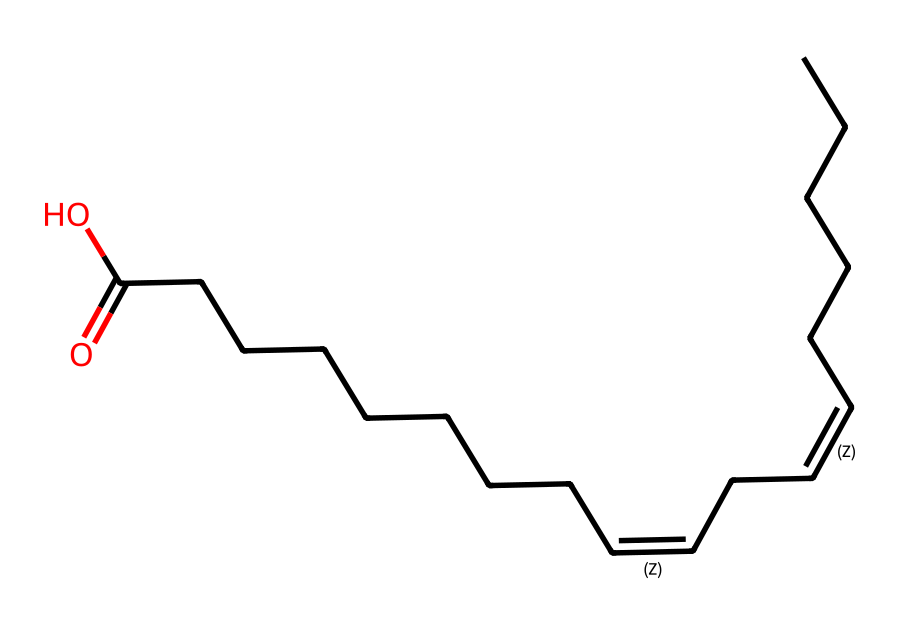What is the main functional group present in this chemical? The chemical contains a carboxylic acid functional group indicated by the -COOH at the end of the chain. This is identified by the carbon (C) double-bonded to an oxygen (O) and single-bonded to a hydroxyl group (OH).
Answer: carboxylic acid How many double bonds are present in this molecule? The visual representation shows two double bonds in the carbon chain connected by the slashes indicating their positions. Each double bond connects two carbon atoms which can be counted from the SMILES.
Answer: two What is the total number of carbon atoms in this chemical? By analyzing the SMILES representation, we can count the individual carbon (C) atoms, in total, there are 18 carbon atoms visible through the long-chain structure.
Answer: eighteen What kind of natural source might this chemical be derived from? Given that this is a long-chain fatty acid with a carboxylic acid at the end, it is likely derived from natural plant oils or fats. These compounds are typically obtained from sources such as vegetable oils or animal fats.
Answer: plant oils Which type of saturation does this chemical exhibit? The presence of double bonds indicates that this compound is unsaturated; saturated compounds would not contain double bonds in their structure.
Answer: unsaturated What property does the presence of the carboxylic acid group impart to this chemical? The carboxylic acid group makes the compound acidic, allowing it to donate protons (H+) in solution. This is a characteristic property of carboxylic acids contributing to reactivity and solubility in water.
Answer: acidic 